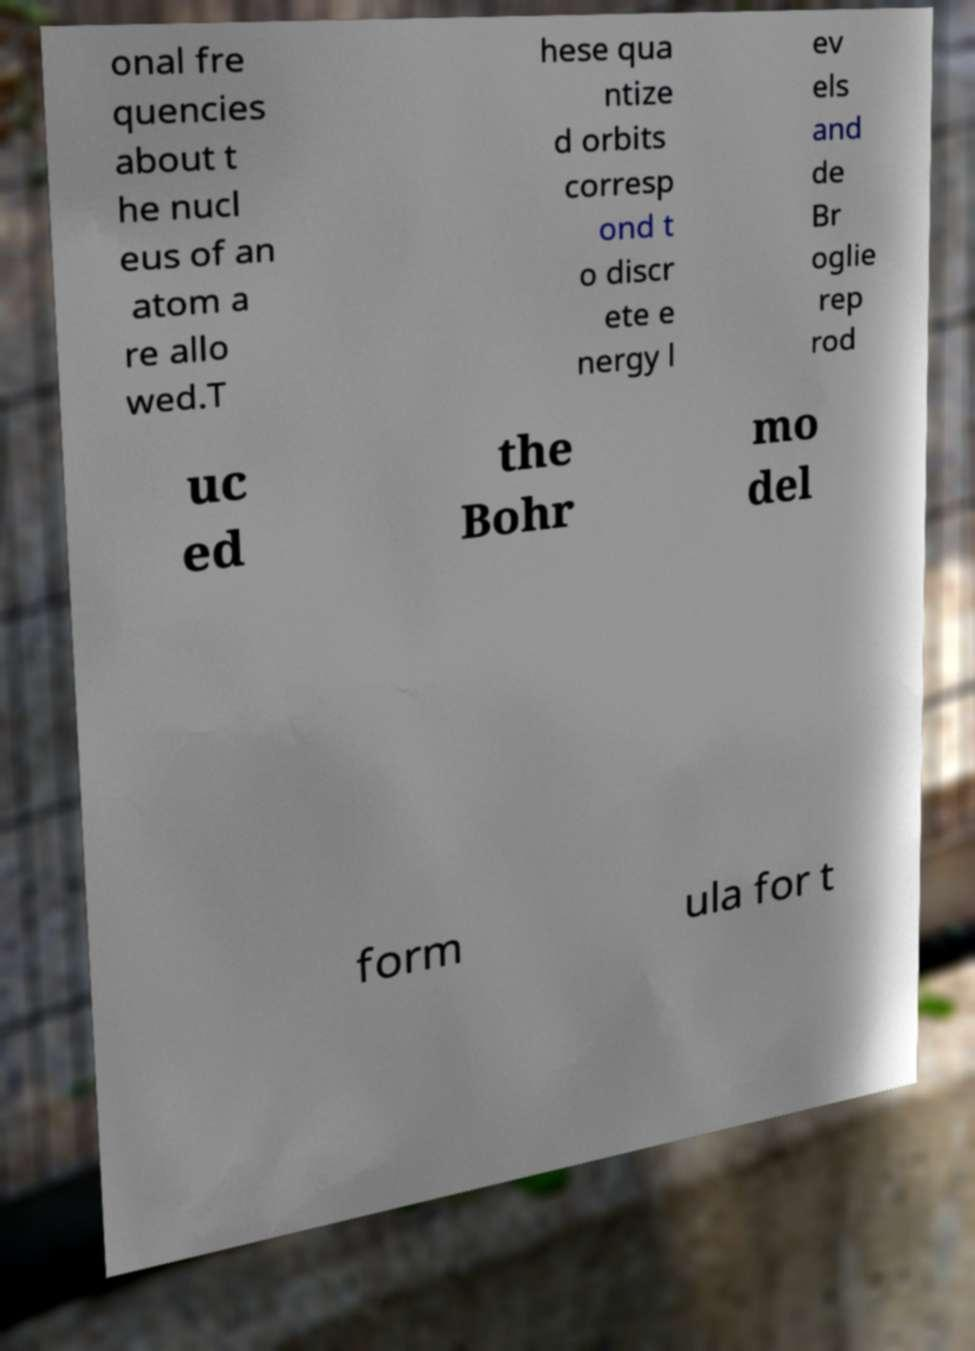Could you extract and type out the text from this image? onal fre quencies about t he nucl eus of an atom a re allo wed.T hese qua ntize d orbits corresp ond t o discr ete e nergy l ev els and de Br oglie rep rod uc ed the Bohr mo del form ula for t 